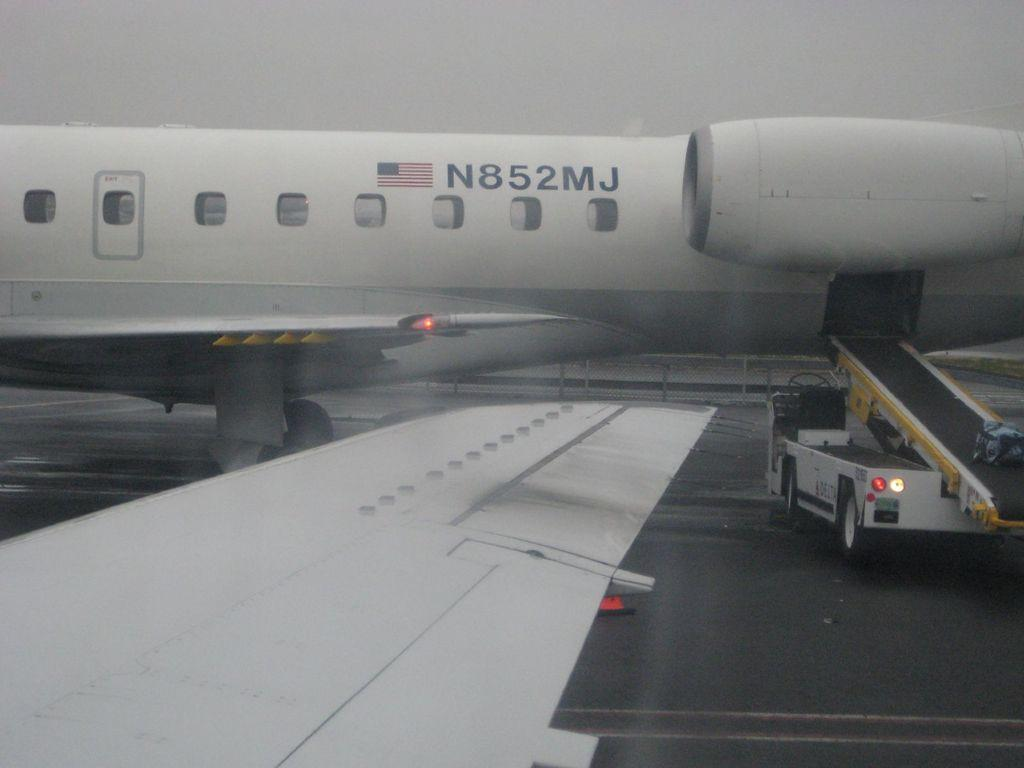What is the main subject of the image? The main subject of the image is an airplane. What else can be seen in the image besides the airplane? There is a vehicle on a runway in the image. How would you describe the sky in the image? The sky is cloudy in the image. What type of error can be seen in the image? There is no error present in the image; it features an airplane and a vehicle on a runway with a cloudy sky. How low is the airplane flying in the image? The image does not provide information about the altitude of the airplane, so it cannot be determined from the picture. 